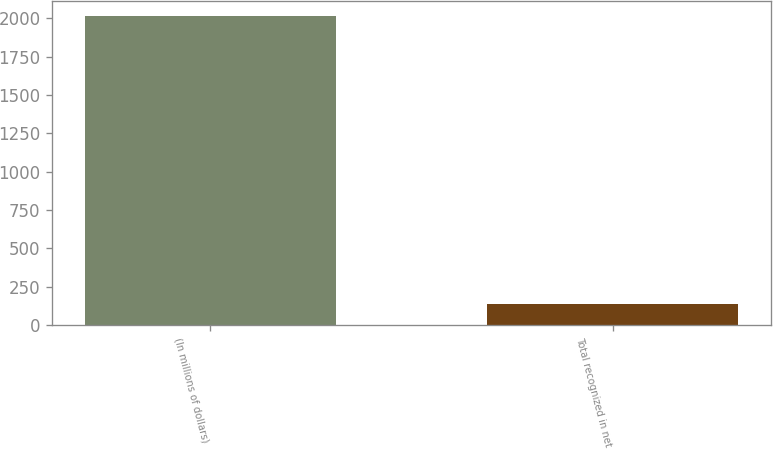Convert chart to OTSL. <chart><loc_0><loc_0><loc_500><loc_500><bar_chart><fcel>(In millions of dollars)<fcel>Total recognized in net<nl><fcel>2015<fcel>138<nl></chart> 